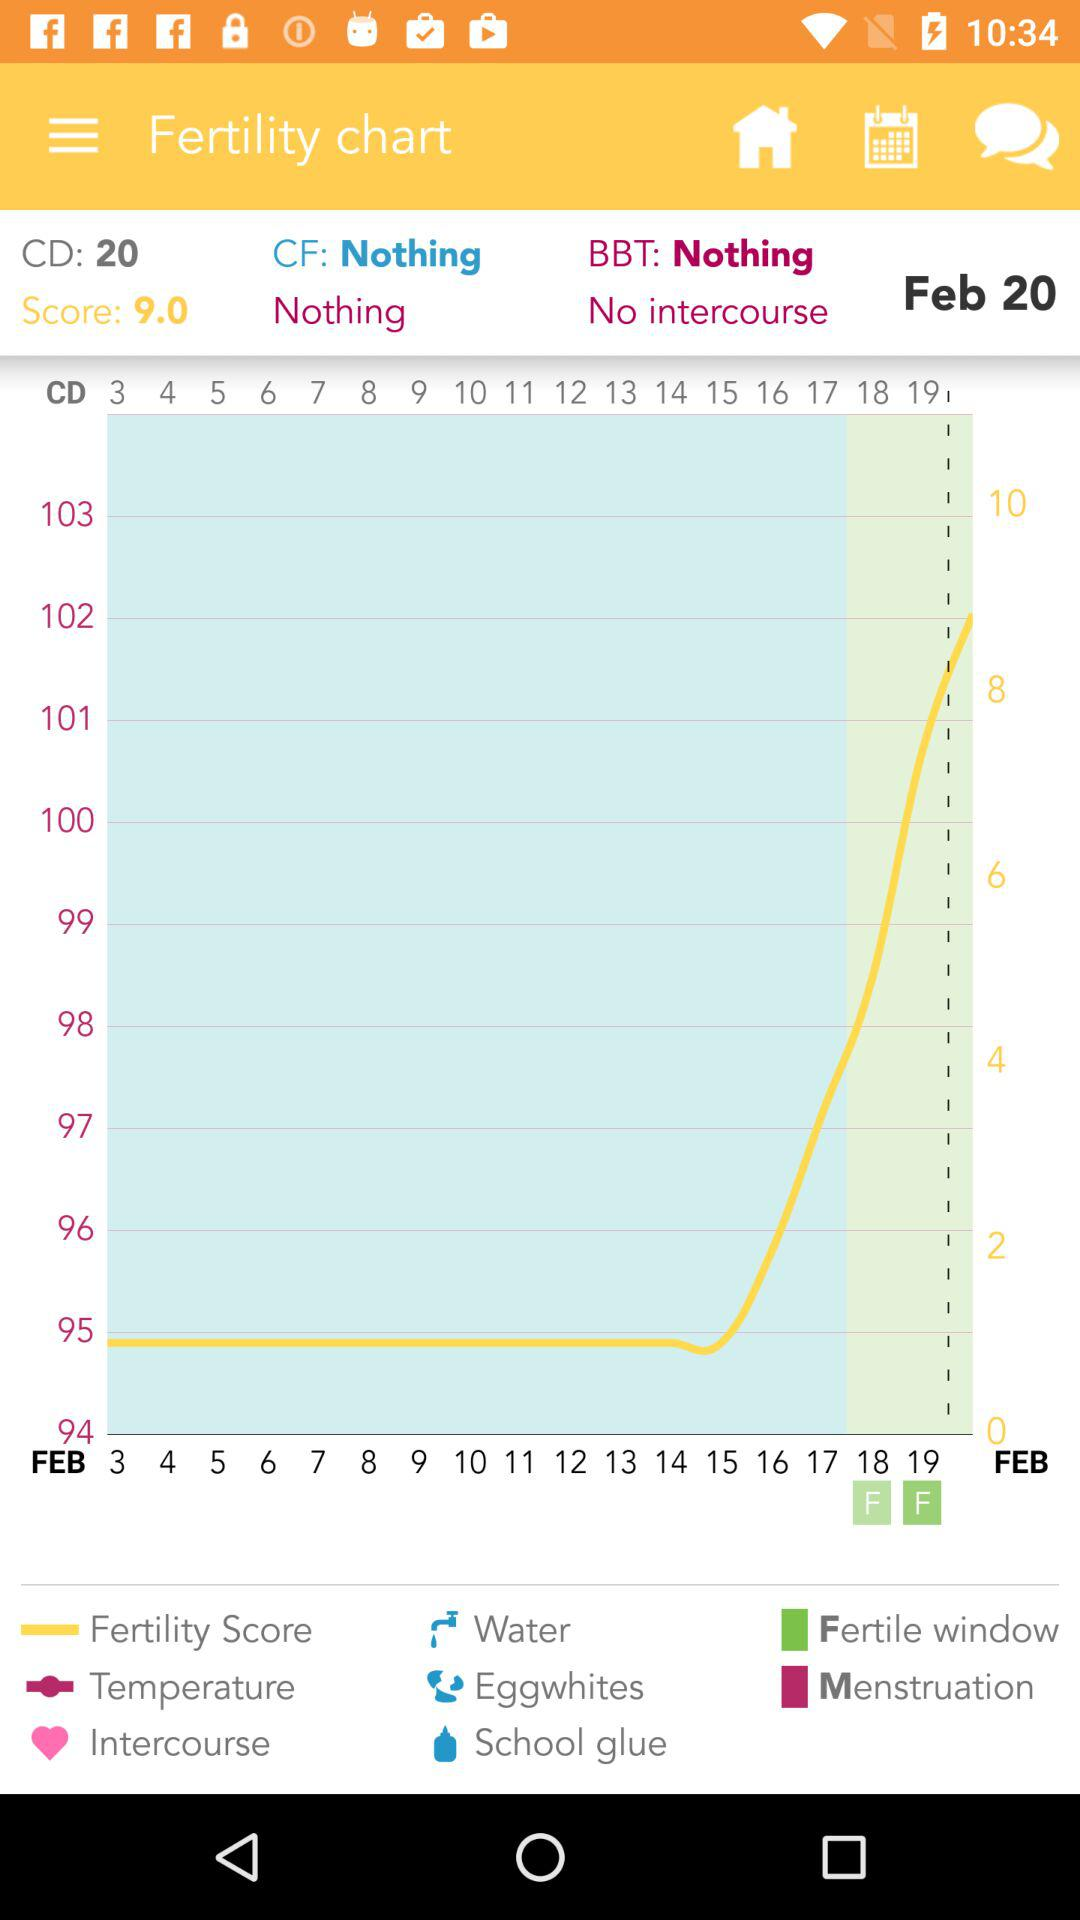What is the highest value in the fertility score column?
Answer the question using a single word or phrase. 9.0 